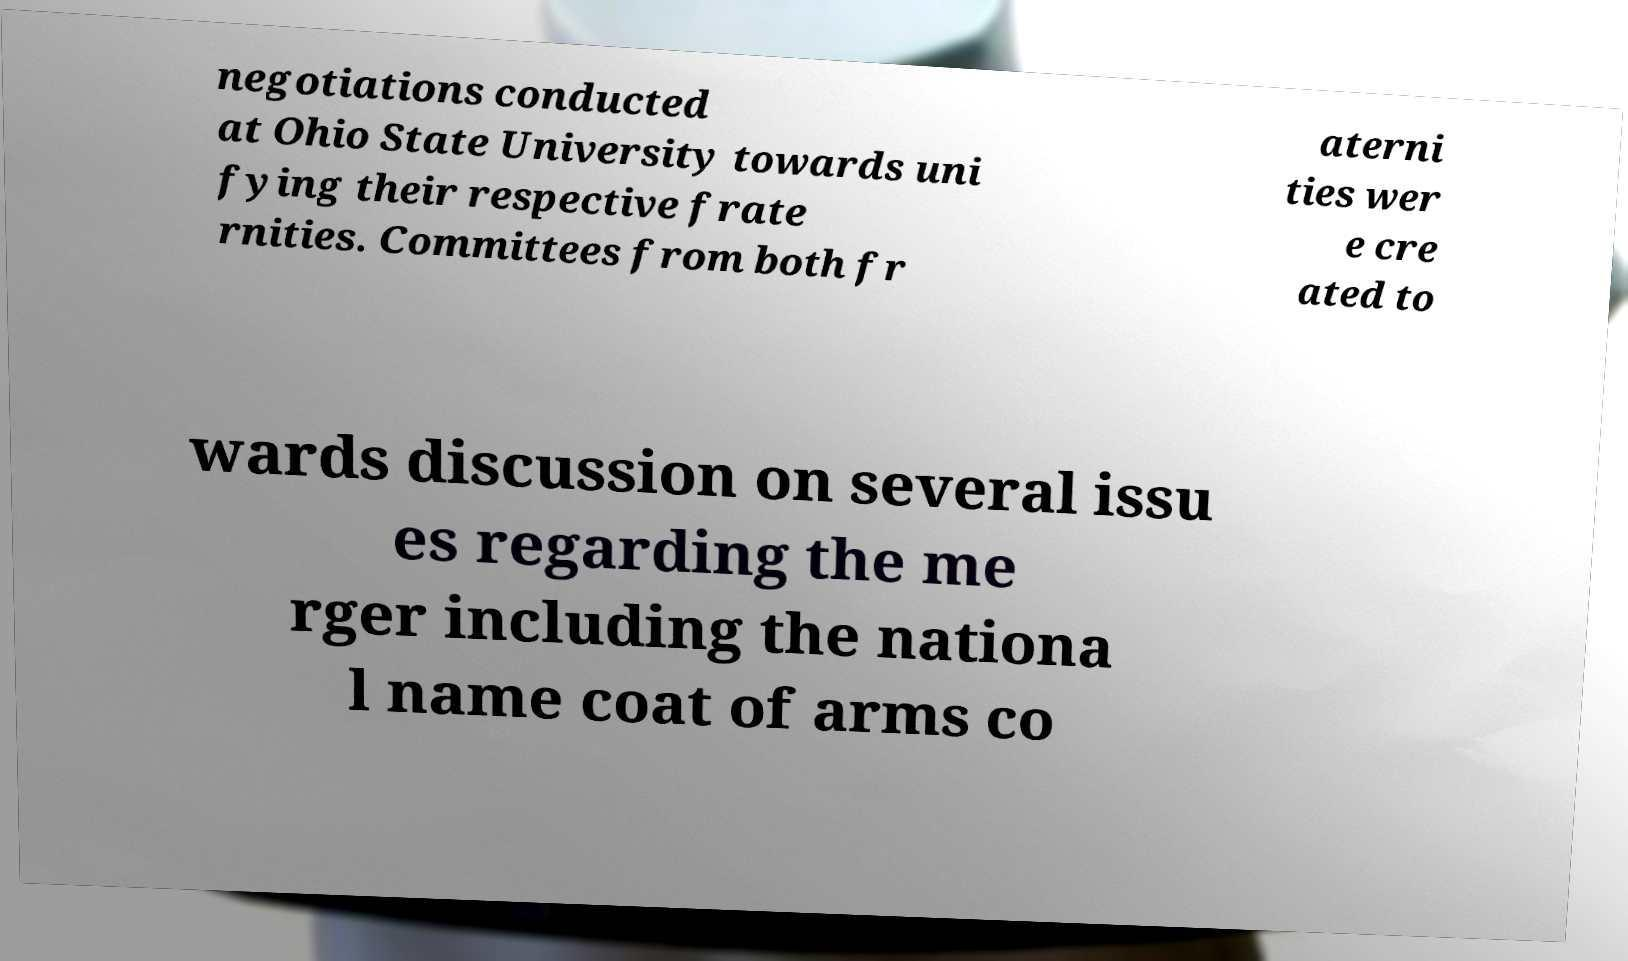Could you extract and type out the text from this image? negotiations conducted at Ohio State University towards uni fying their respective frate rnities. Committees from both fr aterni ties wer e cre ated to wards discussion on several issu es regarding the me rger including the nationa l name coat of arms co 